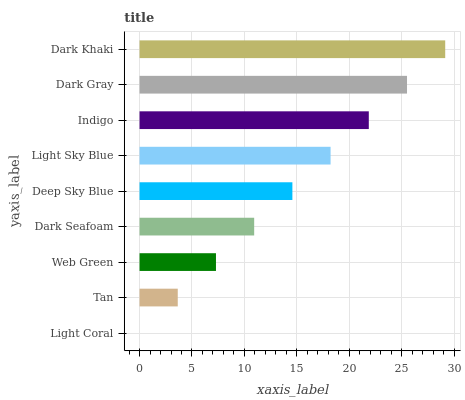Is Light Coral the minimum?
Answer yes or no. Yes. Is Dark Khaki the maximum?
Answer yes or no. Yes. Is Tan the minimum?
Answer yes or no. No. Is Tan the maximum?
Answer yes or no. No. Is Tan greater than Light Coral?
Answer yes or no. Yes. Is Light Coral less than Tan?
Answer yes or no. Yes. Is Light Coral greater than Tan?
Answer yes or no. No. Is Tan less than Light Coral?
Answer yes or no. No. Is Deep Sky Blue the high median?
Answer yes or no. Yes. Is Deep Sky Blue the low median?
Answer yes or no. Yes. Is Light Coral the high median?
Answer yes or no. No. Is Dark Seafoam the low median?
Answer yes or no. No. 